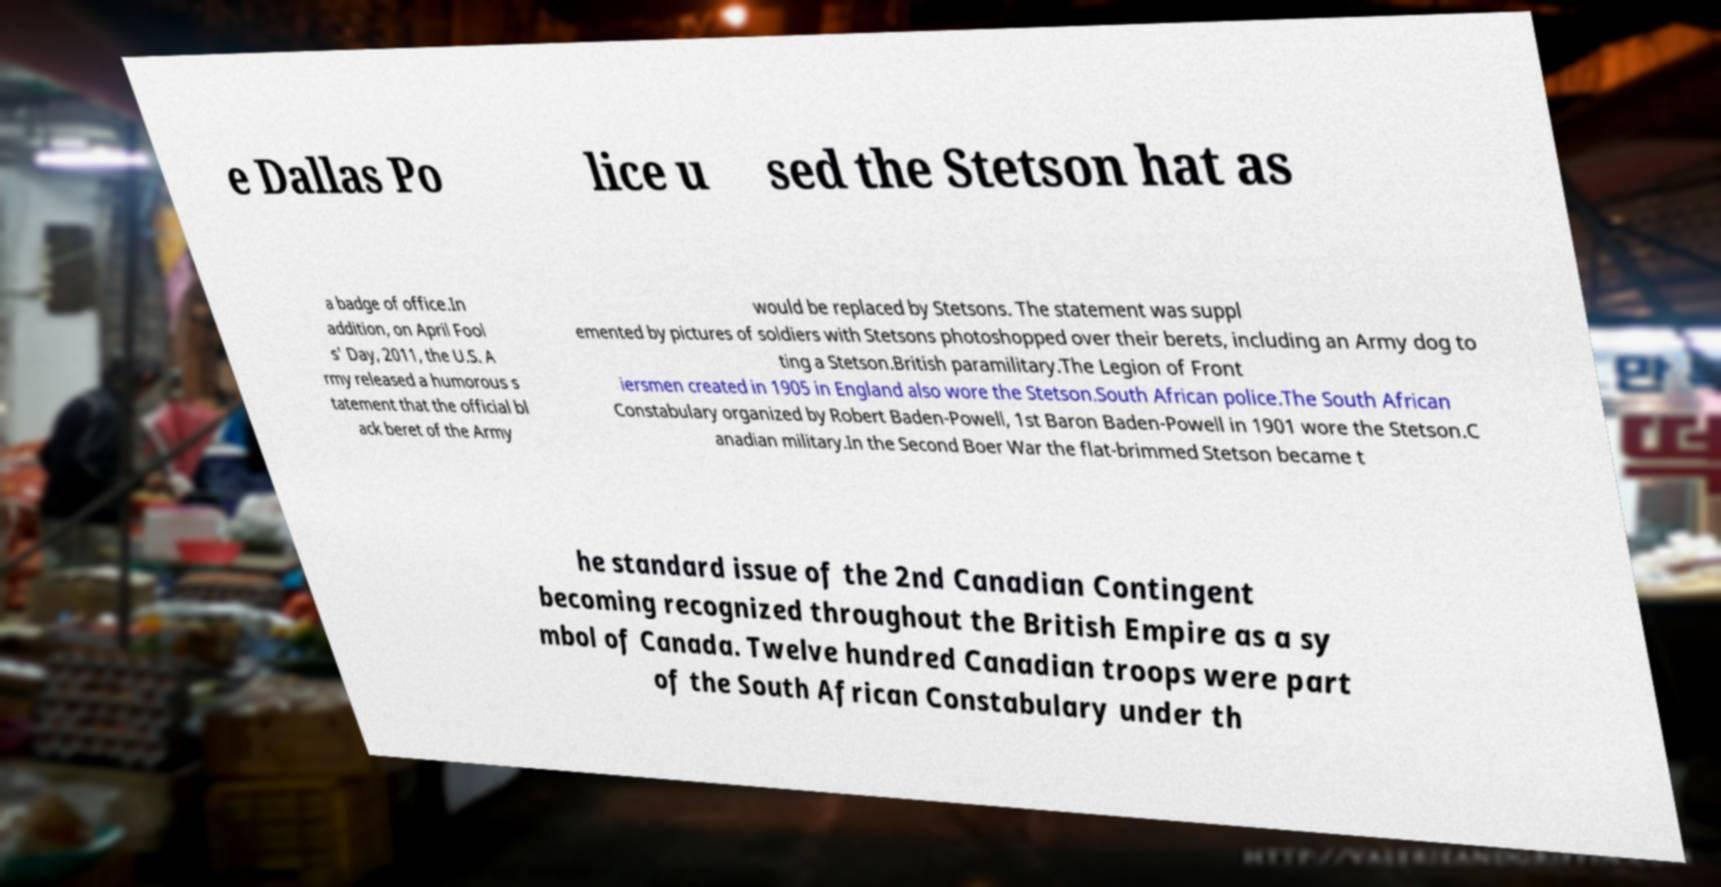Please read and relay the text visible in this image. What does it say? e Dallas Po lice u sed the Stetson hat as a badge of office.In addition, on April Fool s' Day, 2011, the U.S. A rmy released a humorous s tatement that the official bl ack beret of the Army would be replaced by Stetsons. The statement was suppl emented by pictures of soldiers with Stetsons photoshopped over their berets, including an Army dog to ting a Stetson.British paramilitary.The Legion of Front iersmen created in 1905 in England also wore the Stetson.South African police.The South African Constabulary organized by Robert Baden-Powell, 1st Baron Baden-Powell in 1901 wore the Stetson.C anadian military.In the Second Boer War the flat-brimmed Stetson became t he standard issue of the 2nd Canadian Contingent becoming recognized throughout the British Empire as a sy mbol of Canada. Twelve hundred Canadian troops were part of the South African Constabulary under th 